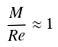Convert formula to latex. <formula><loc_0><loc_0><loc_500><loc_500>\frac { M } { R e } \approx 1</formula> 